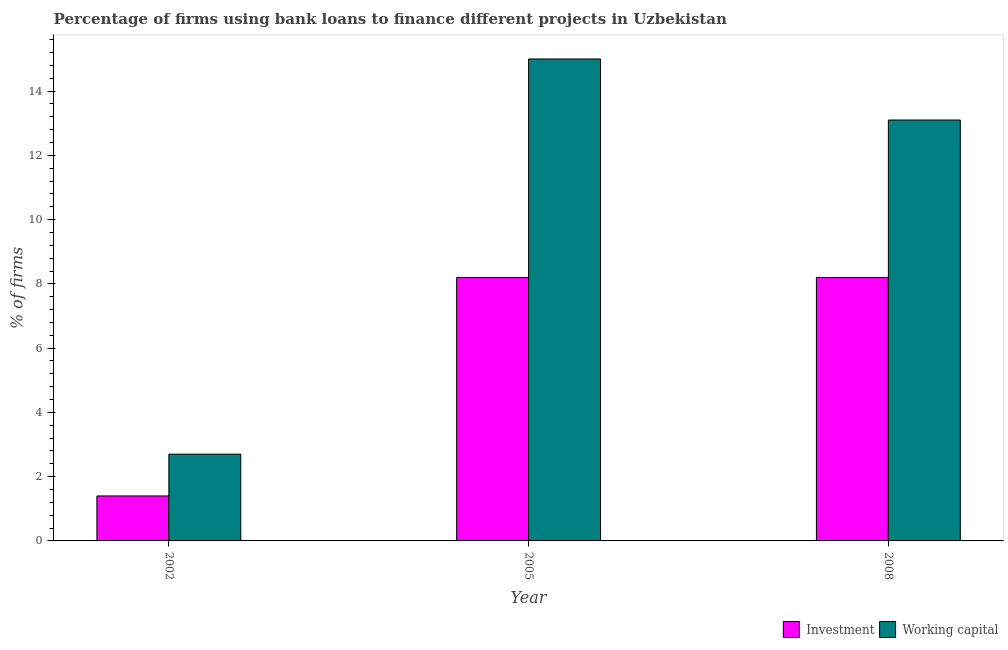How many different coloured bars are there?
Offer a terse response. 2. Are the number of bars per tick equal to the number of legend labels?
Provide a succinct answer. Yes. How many bars are there on the 3rd tick from the left?
Ensure brevity in your answer.  2. How many bars are there on the 3rd tick from the right?
Give a very brief answer. 2. What is the percentage of firms using banks to finance working capital in 2002?
Give a very brief answer. 2.7. Across all years, what is the maximum percentage of firms using banks to finance investment?
Your answer should be very brief. 8.2. What is the total percentage of firms using banks to finance investment in the graph?
Offer a terse response. 17.8. What is the difference between the percentage of firms using banks to finance investment in 2002 and that in 2005?
Keep it short and to the point. -6.8. What is the difference between the percentage of firms using banks to finance investment in 2008 and the percentage of firms using banks to finance working capital in 2002?
Provide a succinct answer. 6.8. What is the average percentage of firms using banks to finance investment per year?
Your answer should be compact. 5.93. In the year 2005, what is the difference between the percentage of firms using banks to finance working capital and percentage of firms using banks to finance investment?
Your answer should be very brief. 0. In how many years, is the percentage of firms using banks to finance working capital greater than 8 %?
Keep it short and to the point. 2. What is the ratio of the percentage of firms using banks to finance working capital in 2005 to that in 2008?
Give a very brief answer. 1.15. Is the percentage of firms using banks to finance working capital in 2002 less than that in 2008?
Provide a short and direct response. Yes. What is the difference between the highest and the second highest percentage of firms using banks to finance working capital?
Your answer should be very brief. 1.9. Is the sum of the percentage of firms using banks to finance working capital in 2002 and 2008 greater than the maximum percentage of firms using banks to finance investment across all years?
Your response must be concise. Yes. What does the 1st bar from the left in 2005 represents?
Give a very brief answer. Investment. What does the 1st bar from the right in 2002 represents?
Your answer should be very brief. Working capital. How many bars are there?
Your answer should be very brief. 6. Are all the bars in the graph horizontal?
Offer a terse response. No. Does the graph contain any zero values?
Give a very brief answer. No. Where does the legend appear in the graph?
Your answer should be compact. Bottom right. How many legend labels are there?
Offer a very short reply. 2. How are the legend labels stacked?
Ensure brevity in your answer.  Horizontal. What is the title of the graph?
Ensure brevity in your answer.  Percentage of firms using bank loans to finance different projects in Uzbekistan. What is the label or title of the X-axis?
Give a very brief answer. Year. What is the label or title of the Y-axis?
Provide a short and direct response. % of firms. What is the % of firms in Investment in 2002?
Give a very brief answer. 1.4. What is the % of firms in Working capital in 2002?
Your response must be concise. 2.7. Across all years, what is the maximum % of firms in Investment?
Offer a very short reply. 8.2. Across all years, what is the minimum % of firms of Working capital?
Your answer should be very brief. 2.7. What is the total % of firms of Working capital in the graph?
Your answer should be very brief. 30.8. What is the difference between the % of firms in Investment in 2002 and that in 2005?
Your answer should be compact. -6.8. What is the difference between the % of firms in Investment in 2002 and that in 2008?
Your answer should be compact. -6.8. What is the difference between the % of firms of Working capital in 2002 and that in 2008?
Your answer should be very brief. -10.4. What is the difference between the % of firms in Investment in 2005 and that in 2008?
Provide a short and direct response. 0. What is the difference between the % of firms of Working capital in 2005 and that in 2008?
Provide a short and direct response. 1.9. What is the difference between the % of firms in Investment in 2002 and the % of firms in Working capital in 2008?
Provide a succinct answer. -11.7. What is the average % of firms in Investment per year?
Provide a short and direct response. 5.93. What is the average % of firms in Working capital per year?
Offer a terse response. 10.27. In the year 2005, what is the difference between the % of firms in Investment and % of firms in Working capital?
Ensure brevity in your answer.  -6.8. In the year 2008, what is the difference between the % of firms in Investment and % of firms in Working capital?
Offer a very short reply. -4.9. What is the ratio of the % of firms of Investment in 2002 to that in 2005?
Your answer should be compact. 0.17. What is the ratio of the % of firms of Working capital in 2002 to that in 2005?
Keep it short and to the point. 0.18. What is the ratio of the % of firms in Investment in 2002 to that in 2008?
Provide a short and direct response. 0.17. What is the ratio of the % of firms in Working capital in 2002 to that in 2008?
Your answer should be compact. 0.21. What is the ratio of the % of firms in Working capital in 2005 to that in 2008?
Make the answer very short. 1.15. What is the difference between the highest and the second highest % of firms in Investment?
Ensure brevity in your answer.  0. What is the difference between the highest and the second highest % of firms of Working capital?
Your response must be concise. 1.9. What is the difference between the highest and the lowest % of firms in Working capital?
Offer a terse response. 12.3. 